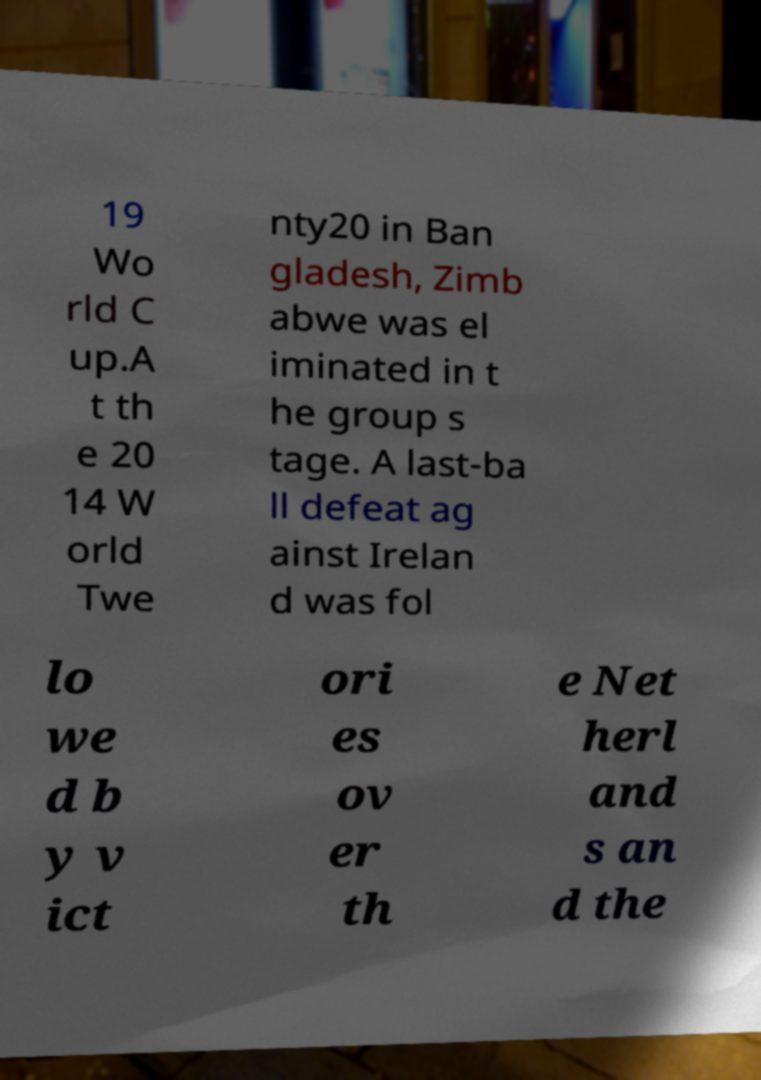Could you assist in decoding the text presented in this image and type it out clearly? 19 Wo rld C up.A t th e 20 14 W orld Twe nty20 in Ban gladesh, Zimb abwe was el iminated in t he group s tage. A last-ba ll defeat ag ainst Irelan d was fol lo we d b y v ict ori es ov er th e Net herl and s an d the 